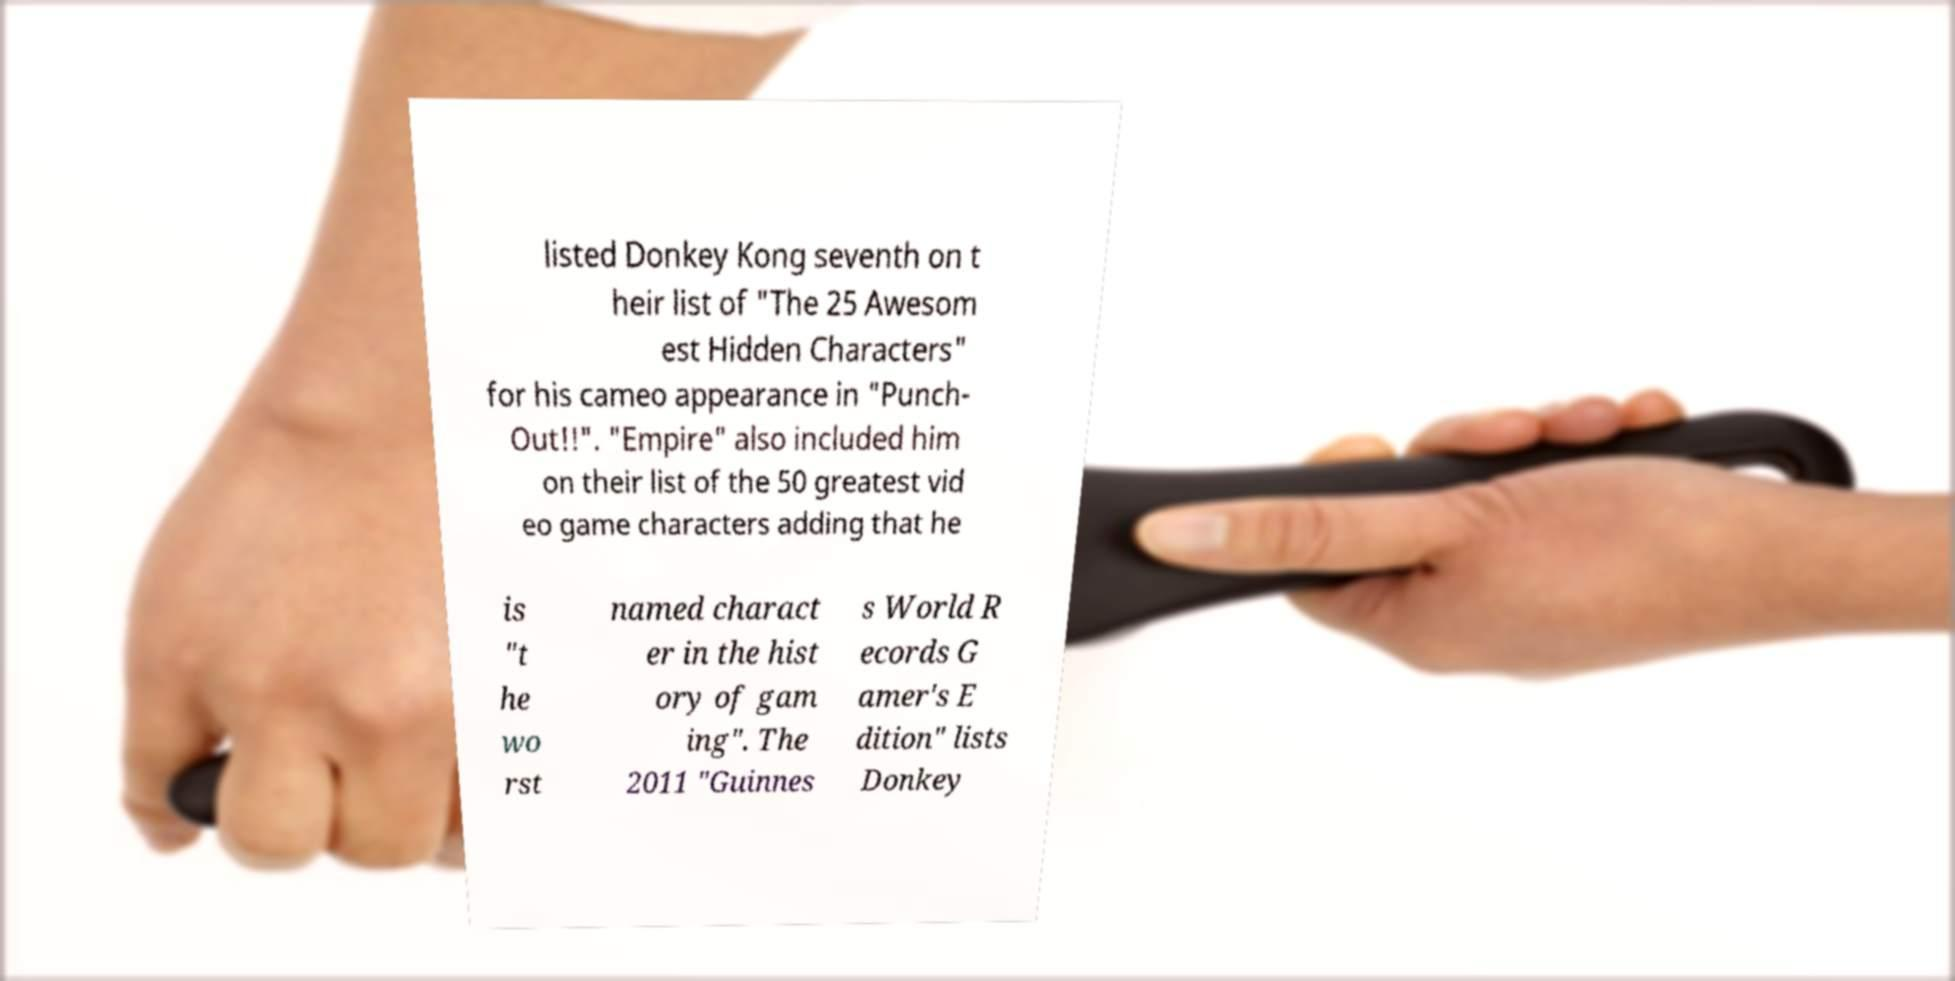What messages or text are displayed in this image? I need them in a readable, typed format. listed Donkey Kong seventh on t heir list of "The 25 Awesom est Hidden Characters" for his cameo appearance in "Punch- Out!!". "Empire" also included him on their list of the 50 greatest vid eo game characters adding that he is "t he wo rst named charact er in the hist ory of gam ing". The 2011 "Guinnes s World R ecords G amer's E dition" lists Donkey 